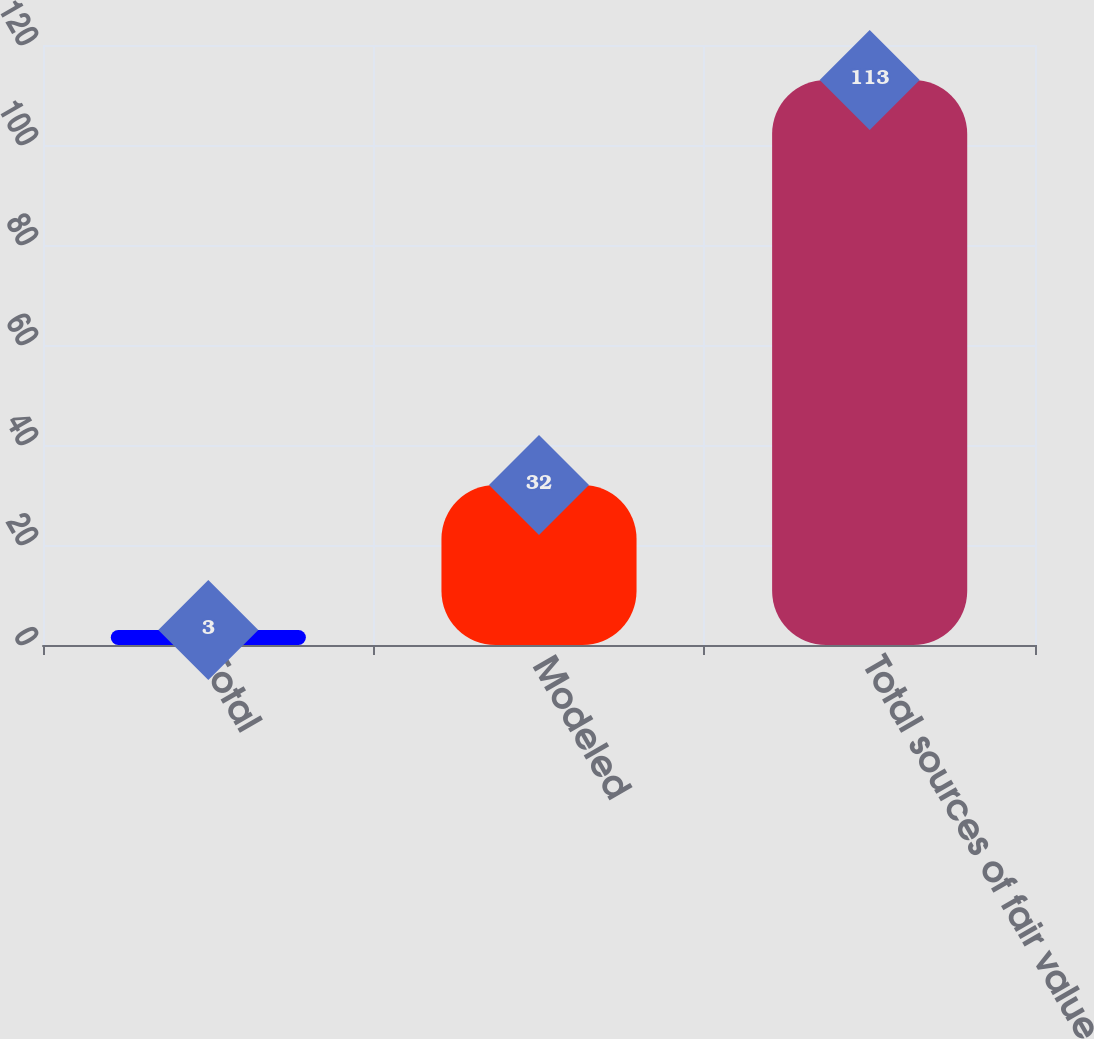Convert chart to OTSL. <chart><loc_0><loc_0><loc_500><loc_500><bar_chart><fcel>Total<fcel>Modeled<fcel>Total sources of fair value<nl><fcel>3<fcel>32<fcel>113<nl></chart> 